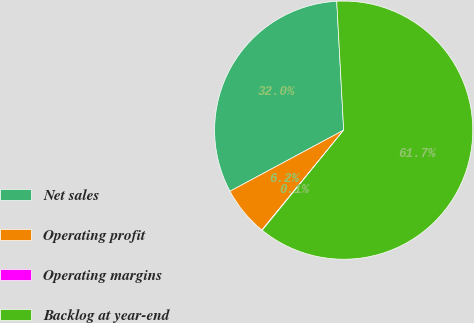<chart> <loc_0><loc_0><loc_500><loc_500><pie_chart><fcel>Net sales<fcel>Operating profit<fcel>Operating margins<fcel>Backlog at year-end<nl><fcel>31.99%<fcel>6.23%<fcel>0.06%<fcel>61.72%<nl></chart> 